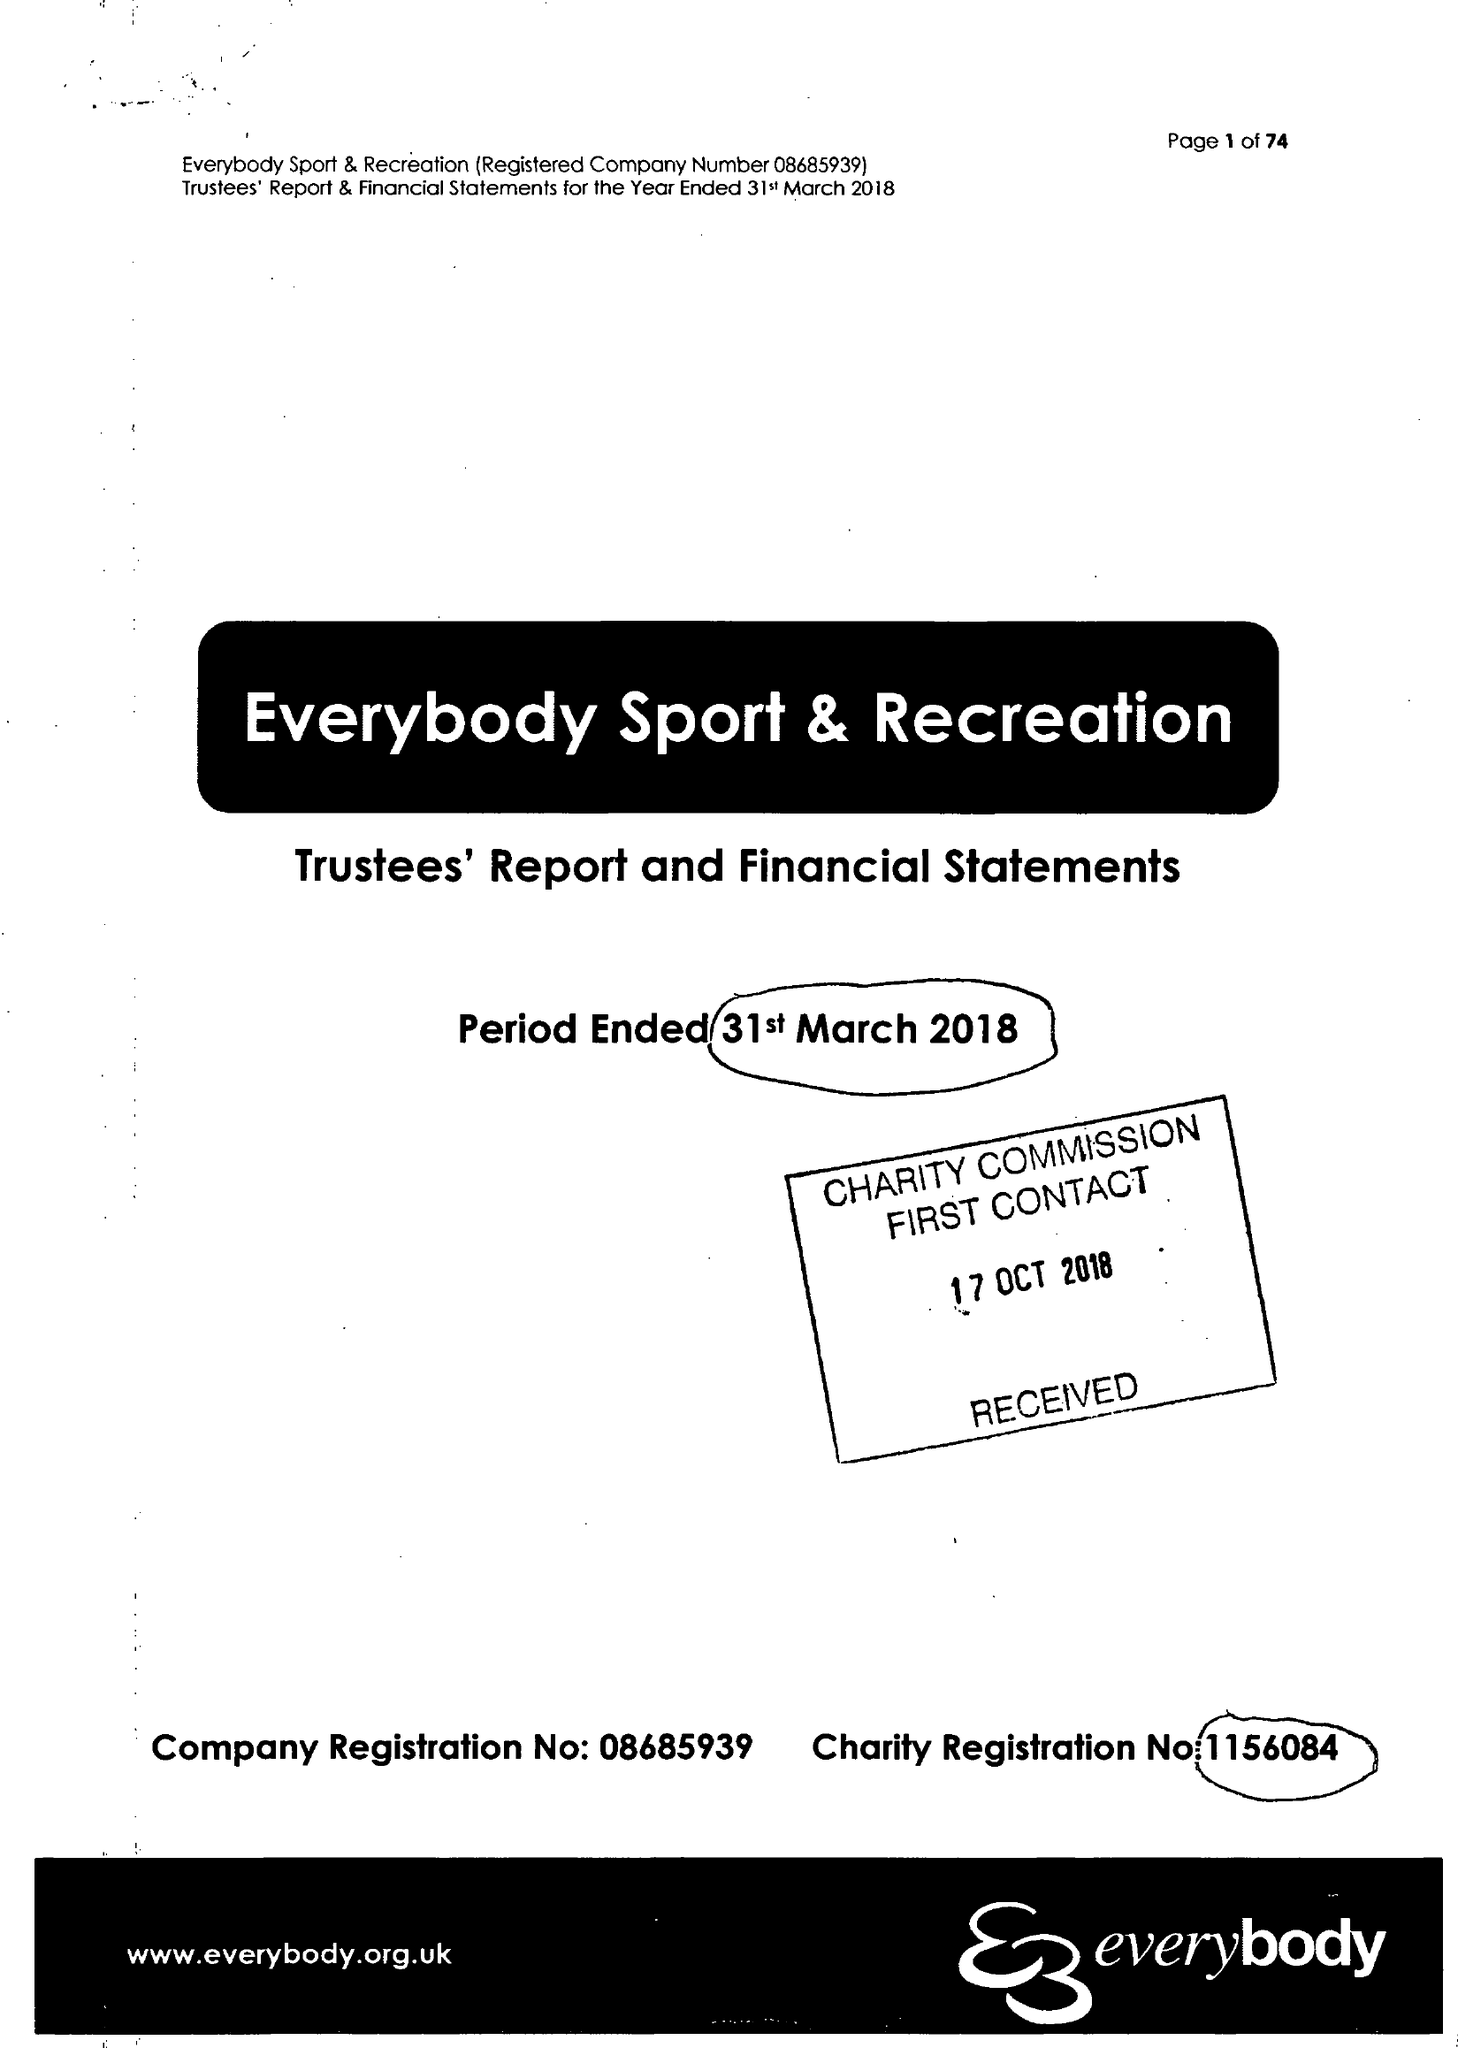What is the value for the charity_name?
Answer the question using a single word or phrase. Everybody Sport and Recreation 